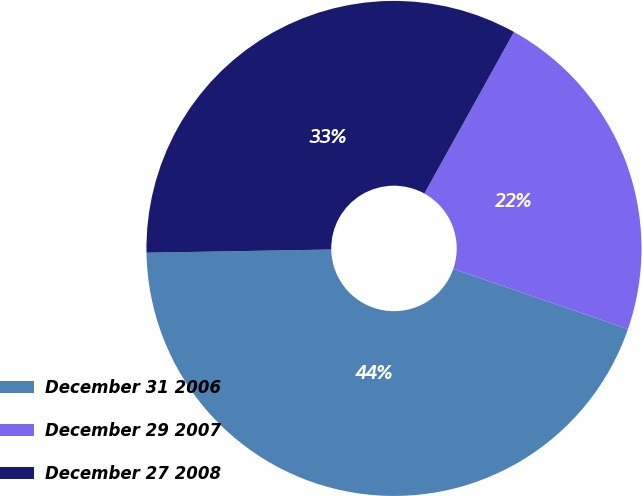<chart> <loc_0><loc_0><loc_500><loc_500><pie_chart><fcel>December 31 2006<fcel>December 29 2007<fcel>December 27 2008<nl><fcel>44.44%<fcel>22.22%<fcel>33.33%<nl></chart> 